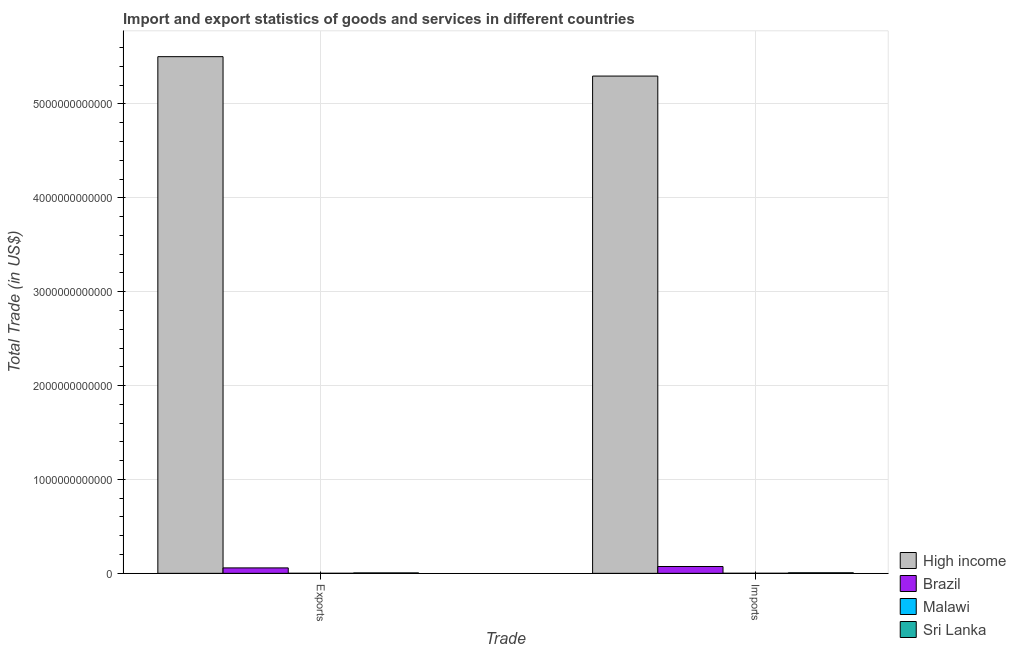Are the number of bars per tick equal to the number of legend labels?
Give a very brief answer. Yes. Are the number of bars on each tick of the X-axis equal?
Provide a succinct answer. Yes. How many bars are there on the 2nd tick from the left?
Keep it short and to the point. 4. What is the label of the 1st group of bars from the left?
Provide a short and direct response. Exports. What is the imports of goods and services in Brazil?
Ensure brevity in your answer.  7.28e+1. Across all countries, what is the maximum imports of goods and services?
Ensure brevity in your answer.  5.30e+12. Across all countries, what is the minimum export of goods and services?
Provide a succinct answer. 4.24e+08. In which country was the imports of goods and services minimum?
Your answer should be compact. Malawi. What is the total imports of goods and services in the graph?
Ensure brevity in your answer.  5.38e+12. What is the difference between the imports of goods and services in Brazil and that in Sri Lanka?
Your answer should be very brief. 6.68e+1. What is the difference between the imports of goods and services in Brazil and the export of goods and services in Sri Lanka?
Provide a succinct answer. 6.81e+1. What is the average export of goods and services per country?
Your response must be concise. 1.39e+12. What is the difference between the export of goods and services and imports of goods and services in Sri Lanka?
Provide a succinct answer. -1.36e+09. What is the ratio of the imports of goods and services in Malawi to that in High income?
Provide a short and direct response. 0. What does the 3rd bar from the left in Exports represents?
Your answer should be very brief. Malawi. What does the 1st bar from the right in Imports represents?
Keep it short and to the point. Sri Lanka. Are all the bars in the graph horizontal?
Your answer should be very brief. No. How many countries are there in the graph?
Your answer should be very brief. 4. What is the difference between two consecutive major ticks on the Y-axis?
Offer a terse response. 1.00e+12. Does the graph contain any zero values?
Keep it short and to the point. No. Where does the legend appear in the graph?
Give a very brief answer. Bottom right. How many legend labels are there?
Make the answer very short. 4. How are the legend labels stacked?
Keep it short and to the point. Vertical. What is the title of the graph?
Ensure brevity in your answer.  Import and export statistics of goods and services in different countries. Does "Marshall Islands" appear as one of the legend labels in the graph?
Keep it short and to the point. No. What is the label or title of the X-axis?
Your response must be concise. Trade. What is the label or title of the Y-axis?
Ensure brevity in your answer.  Total Trade (in US$). What is the Total Trade (in US$) in High income in Exports?
Offer a very short reply. 5.50e+12. What is the Total Trade (in US$) of Brazil in Exports?
Provide a succinct answer. 5.79e+1. What is the Total Trade (in US$) in Malawi in Exports?
Provide a succinct answer. 4.24e+08. What is the Total Trade (in US$) of Sri Lanka in Exports?
Give a very brief answer. 4.64e+09. What is the Total Trade (in US$) in High income in Imports?
Keep it short and to the point. 5.30e+12. What is the Total Trade (in US$) of Brazil in Imports?
Your response must be concise. 7.28e+1. What is the Total Trade (in US$) in Malawi in Imports?
Your answer should be compact. 6.72e+08. What is the Total Trade (in US$) of Sri Lanka in Imports?
Give a very brief answer. 6.00e+09. Across all Trade, what is the maximum Total Trade (in US$) of High income?
Offer a very short reply. 5.50e+12. Across all Trade, what is the maximum Total Trade (in US$) in Brazil?
Offer a terse response. 7.28e+1. Across all Trade, what is the maximum Total Trade (in US$) in Malawi?
Keep it short and to the point. 6.72e+08. Across all Trade, what is the maximum Total Trade (in US$) of Sri Lanka?
Your answer should be very brief. 6.00e+09. Across all Trade, what is the minimum Total Trade (in US$) in High income?
Ensure brevity in your answer.  5.30e+12. Across all Trade, what is the minimum Total Trade (in US$) of Brazil?
Your answer should be very brief. 5.79e+1. Across all Trade, what is the minimum Total Trade (in US$) of Malawi?
Your answer should be compact. 4.24e+08. Across all Trade, what is the minimum Total Trade (in US$) of Sri Lanka?
Your response must be concise. 4.64e+09. What is the total Total Trade (in US$) in High income in the graph?
Your answer should be very brief. 1.08e+13. What is the total Total Trade (in US$) in Brazil in the graph?
Provide a succinct answer. 1.31e+11. What is the total Total Trade (in US$) of Malawi in the graph?
Make the answer very short. 1.10e+09. What is the total Total Trade (in US$) in Sri Lanka in the graph?
Give a very brief answer. 1.06e+1. What is the difference between the Total Trade (in US$) in High income in Exports and that in Imports?
Provide a short and direct response. 2.07e+11. What is the difference between the Total Trade (in US$) of Brazil in Exports and that in Imports?
Provide a succinct answer. -1.48e+1. What is the difference between the Total Trade (in US$) in Malawi in Exports and that in Imports?
Provide a succinct answer. -2.48e+08. What is the difference between the Total Trade (in US$) of Sri Lanka in Exports and that in Imports?
Ensure brevity in your answer.  -1.36e+09. What is the difference between the Total Trade (in US$) in High income in Exports and the Total Trade (in US$) in Brazil in Imports?
Provide a succinct answer. 5.43e+12. What is the difference between the Total Trade (in US$) in High income in Exports and the Total Trade (in US$) in Malawi in Imports?
Your answer should be very brief. 5.50e+12. What is the difference between the Total Trade (in US$) in High income in Exports and the Total Trade (in US$) in Sri Lanka in Imports?
Give a very brief answer. 5.50e+12. What is the difference between the Total Trade (in US$) of Brazil in Exports and the Total Trade (in US$) of Malawi in Imports?
Offer a terse response. 5.72e+1. What is the difference between the Total Trade (in US$) of Brazil in Exports and the Total Trade (in US$) of Sri Lanka in Imports?
Give a very brief answer. 5.19e+1. What is the difference between the Total Trade (in US$) of Malawi in Exports and the Total Trade (in US$) of Sri Lanka in Imports?
Provide a short and direct response. -5.57e+09. What is the average Total Trade (in US$) in High income per Trade?
Your response must be concise. 5.40e+12. What is the average Total Trade (in US$) of Brazil per Trade?
Make the answer very short. 6.53e+1. What is the average Total Trade (in US$) of Malawi per Trade?
Ensure brevity in your answer.  5.48e+08. What is the average Total Trade (in US$) in Sri Lanka per Trade?
Give a very brief answer. 5.32e+09. What is the difference between the Total Trade (in US$) of High income and Total Trade (in US$) of Brazil in Exports?
Give a very brief answer. 5.45e+12. What is the difference between the Total Trade (in US$) in High income and Total Trade (in US$) in Malawi in Exports?
Offer a terse response. 5.50e+12. What is the difference between the Total Trade (in US$) in High income and Total Trade (in US$) in Sri Lanka in Exports?
Provide a short and direct response. 5.50e+12. What is the difference between the Total Trade (in US$) in Brazil and Total Trade (in US$) in Malawi in Exports?
Provide a short and direct response. 5.75e+1. What is the difference between the Total Trade (in US$) in Brazil and Total Trade (in US$) in Sri Lanka in Exports?
Your answer should be very brief. 5.33e+1. What is the difference between the Total Trade (in US$) in Malawi and Total Trade (in US$) in Sri Lanka in Exports?
Offer a very short reply. -4.21e+09. What is the difference between the Total Trade (in US$) in High income and Total Trade (in US$) in Brazil in Imports?
Your answer should be very brief. 5.22e+12. What is the difference between the Total Trade (in US$) in High income and Total Trade (in US$) in Malawi in Imports?
Keep it short and to the point. 5.30e+12. What is the difference between the Total Trade (in US$) of High income and Total Trade (in US$) of Sri Lanka in Imports?
Your answer should be compact. 5.29e+12. What is the difference between the Total Trade (in US$) of Brazil and Total Trade (in US$) of Malawi in Imports?
Make the answer very short. 7.21e+1. What is the difference between the Total Trade (in US$) in Brazil and Total Trade (in US$) in Sri Lanka in Imports?
Offer a very short reply. 6.68e+1. What is the difference between the Total Trade (in US$) in Malawi and Total Trade (in US$) in Sri Lanka in Imports?
Your response must be concise. -5.33e+09. What is the ratio of the Total Trade (in US$) of High income in Exports to that in Imports?
Keep it short and to the point. 1.04. What is the ratio of the Total Trade (in US$) in Brazil in Exports to that in Imports?
Offer a very short reply. 0.8. What is the ratio of the Total Trade (in US$) of Malawi in Exports to that in Imports?
Your answer should be very brief. 0.63. What is the ratio of the Total Trade (in US$) in Sri Lanka in Exports to that in Imports?
Offer a terse response. 0.77. What is the difference between the highest and the second highest Total Trade (in US$) of High income?
Your answer should be compact. 2.07e+11. What is the difference between the highest and the second highest Total Trade (in US$) in Brazil?
Your answer should be compact. 1.48e+1. What is the difference between the highest and the second highest Total Trade (in US$) in Malawi?
Ensure brevity in your answer.  2.48e+08. What is the difference between the highest and the second highest Total Trade (in US$) of Sri Lanka?
Your response must be concise. 1.36e+09. What is the difference between the highest and the lowest Total Trade (in US$) of High income?
Offer a terse response. 2.07e+11. What is the difference between the highest and the lowest Total Trade (in US$) in Brazil?
Provide a succinct answer. 1.48e+1. What is the difference between the highest and the lowest Total Trade (in US$) of Malawi?
Ensure brevity in your answer.  2.48e+08. What is the difference between the highest and the lowest Total Trade (in US$) in Sri Lanka?
Your answer should be very brief. 1.36e+09. 